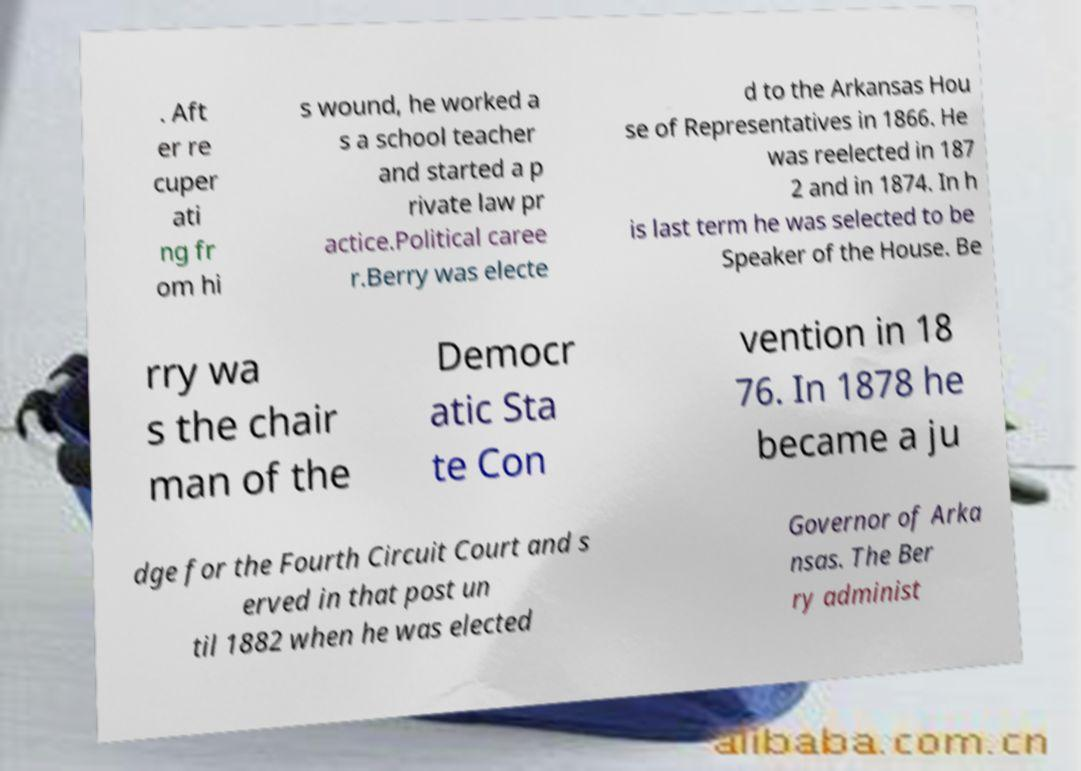Can you read and provide the text displayed in the image?This photo seems to have some interesting text. Can you extract and type it out for me? . Aft er re cuper ati ng fr om hi s wound, he worked a s a school teacher and started a p rivate law pr actice.Political caree r.Berry was electe d to the Arkansas Hou se of Representatives in 1866. He was reelected in 187 2 and in 1874. In h is last term he was selected to be Speaker of the House. Be rry wa s the chair man of the Democr atic Sta te Con vention in 18 76. In 1878 he became a ju dge for the Fourth Circuit Court and s erved in that post un til 1882 when he was elected Governor of Arka nsas. The Ber ry administ 